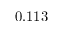Convert formula to latex. <formula><loc_0><loc_0><loc_500><loc_500>0 . 1 1 3</formula> 